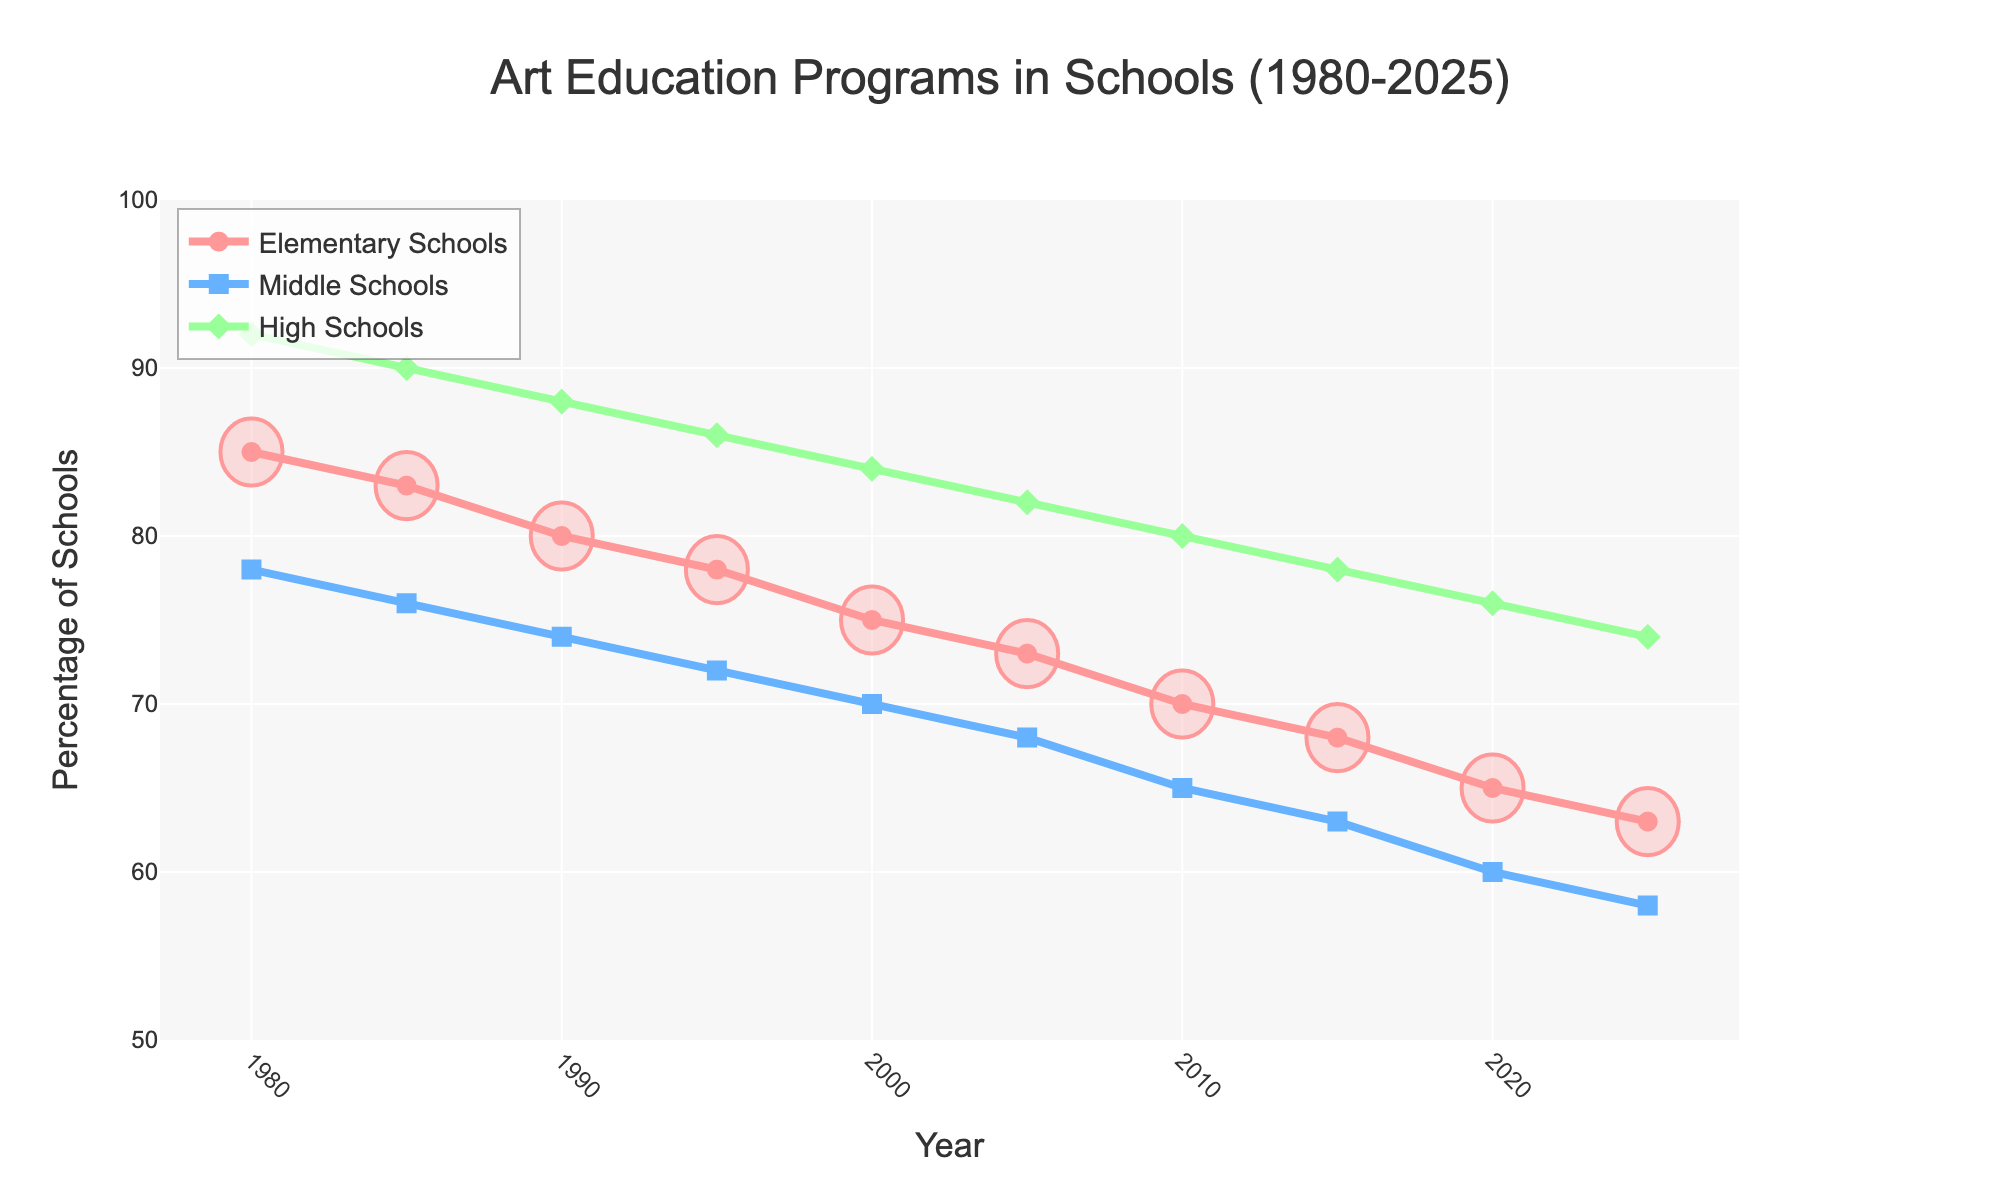What's the trend of art education programs offered in elementary schools from 1980 to 2025? The percentage of elementary schools offering art education programs shows a gradual decline, going from 85% in 1980 to 63% in 2025. This downward trend is steady throughout the period.
Answer: Gradual decline Compare the percentage of high schools offering art education programs in 1980 to middle schools in 2005. Which is higher? In 1980, the percentage of high schools offering art education programs is 92%. In 2005, the percentage for middle schools is 68%. To compare, 92% is higher than 68%.
Answer: High schools in 1980 What is the average percentage of middle schools offering art education programs over the years 1990, 2000, and 2010? The data points for middle schools in 1990, 2000, and 2010 are 74%, 70%, and 65% respectively. The average is calculated as (74 + 70 + 65) / 3 = 69.67%.
Answer: 69.67% Which year shows the smallest gap between the percentages of elementary and high schools offering art education programs? To find the smallest gap, we need to calculate the difference between the percentages of elementary and high schools for each year. The smallest gap is in 2010, with a difference of 70% - 80% = 10%.
Answer: 2010 By how much did the percentage of elementary schools offering art education programs change from 1980 to 2000? The percentage of elementary schools offering art education programs in 1980 was 85% and in 2000 it was 75%. The change is calculated as 85% - 75% = 10%.
Answer: 10% Which school level had the steepest decline in the percentage of schools offering art education programs from 1980 to 2025? To determine the steepest decline, compare the differences for each level: Elementary (85% to 63%, a decline of 22%), Middle (78% to 58%, a decline of 20%), and High (92% to 74%, a decline of 18%). Elementary schools experienced the steepest decline.
Answer: Elementary schools How does the percentage of middle schools offering art education programs in 1995 compare to the percentage in 2025? In 1995, the percentage of middle schools offering art education programs was 72%. In 2025, it was 58%. Comparing these, 72% is greater than 58%.
Answer: 1995 higher What's the combined total percentage of schools offering art education programs across all school levels in 1985? In 1985, the percentages are 83% for elementary schools, 76% for middle schools, and 90% for high schools. The combined total is 83% + 76% + 90% = 249%.
Answer: 249% Which school level has the most consistent decline trend from 1980 to 2025? By examining the lines for each school level, the elementary schools' trend appears to be the most consistent, showing a steady and gradual decline without fluctuations.
Answer: Elementary schools 